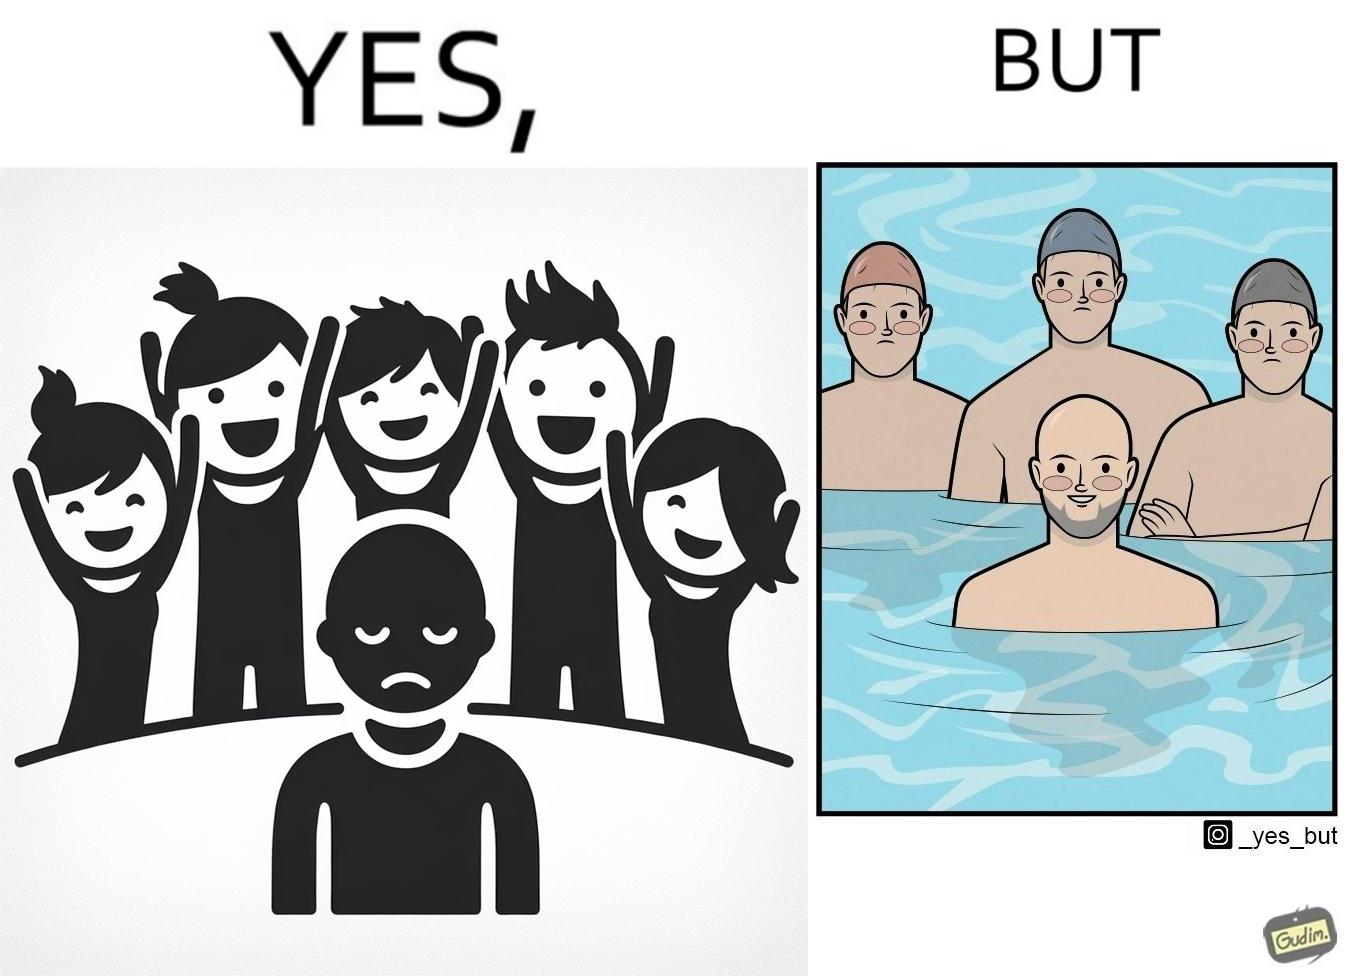Provide a description of this image. The image is ironical, as person without hair is sad in a normal situation due to the absence of hair, unlike other people with hair. However, in a swimming pool, people with hair have to wear swimming caps, which is uncomfortable, while the person without hair does not need a cap, and is thus, happy in this situation. 